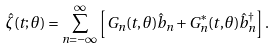Convert formula to latex. <formula><loc_0><loc_0><loc_500><loc_500>\hat { \zeta } ( t ; \theta ) = \sum _ { n = - \infty } ^ { \infty } \left [ G _ { n } ( t , \theta ) \hat { b } _ { n } + G _ { n } ^ { * } ( t , \theta ) \hat { b } _ { n } ^ { \dagger } \right ] .</formula> 